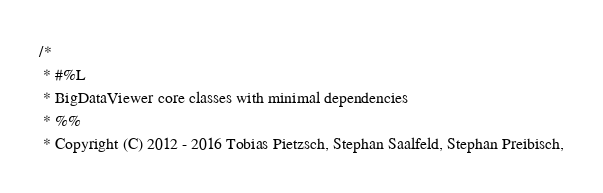<code> <loc_0><loc_0><loc_500><loc_500><_Java_>/*
 * #%L
 * BigDataViewer core classes with minimal dependencies
 * %%
 * Copyright (C) 2012 - 2016 Tobias Pietzsch, Stephan Saalfeld, Stephan Preibisch,</code> 